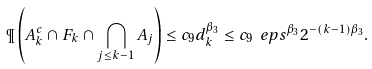Convert formula to latex. <formula><loc_0><loc_0><loc_500><loc_500>\P \left ( A ^ { c } _ { k } \cap F _ { k } \cap \bigcap _ { j \leq k - 1 } A _ { j } \right ) \leq c _ { 9 } d _ { k } ^ { \beta _ { 3 } } \leq c _ { 9 } \ e p s ^ { \beta _ { 3 } } 2 ^ { - ( k - 1 ) \beta _ { 3 } } .</formula> 